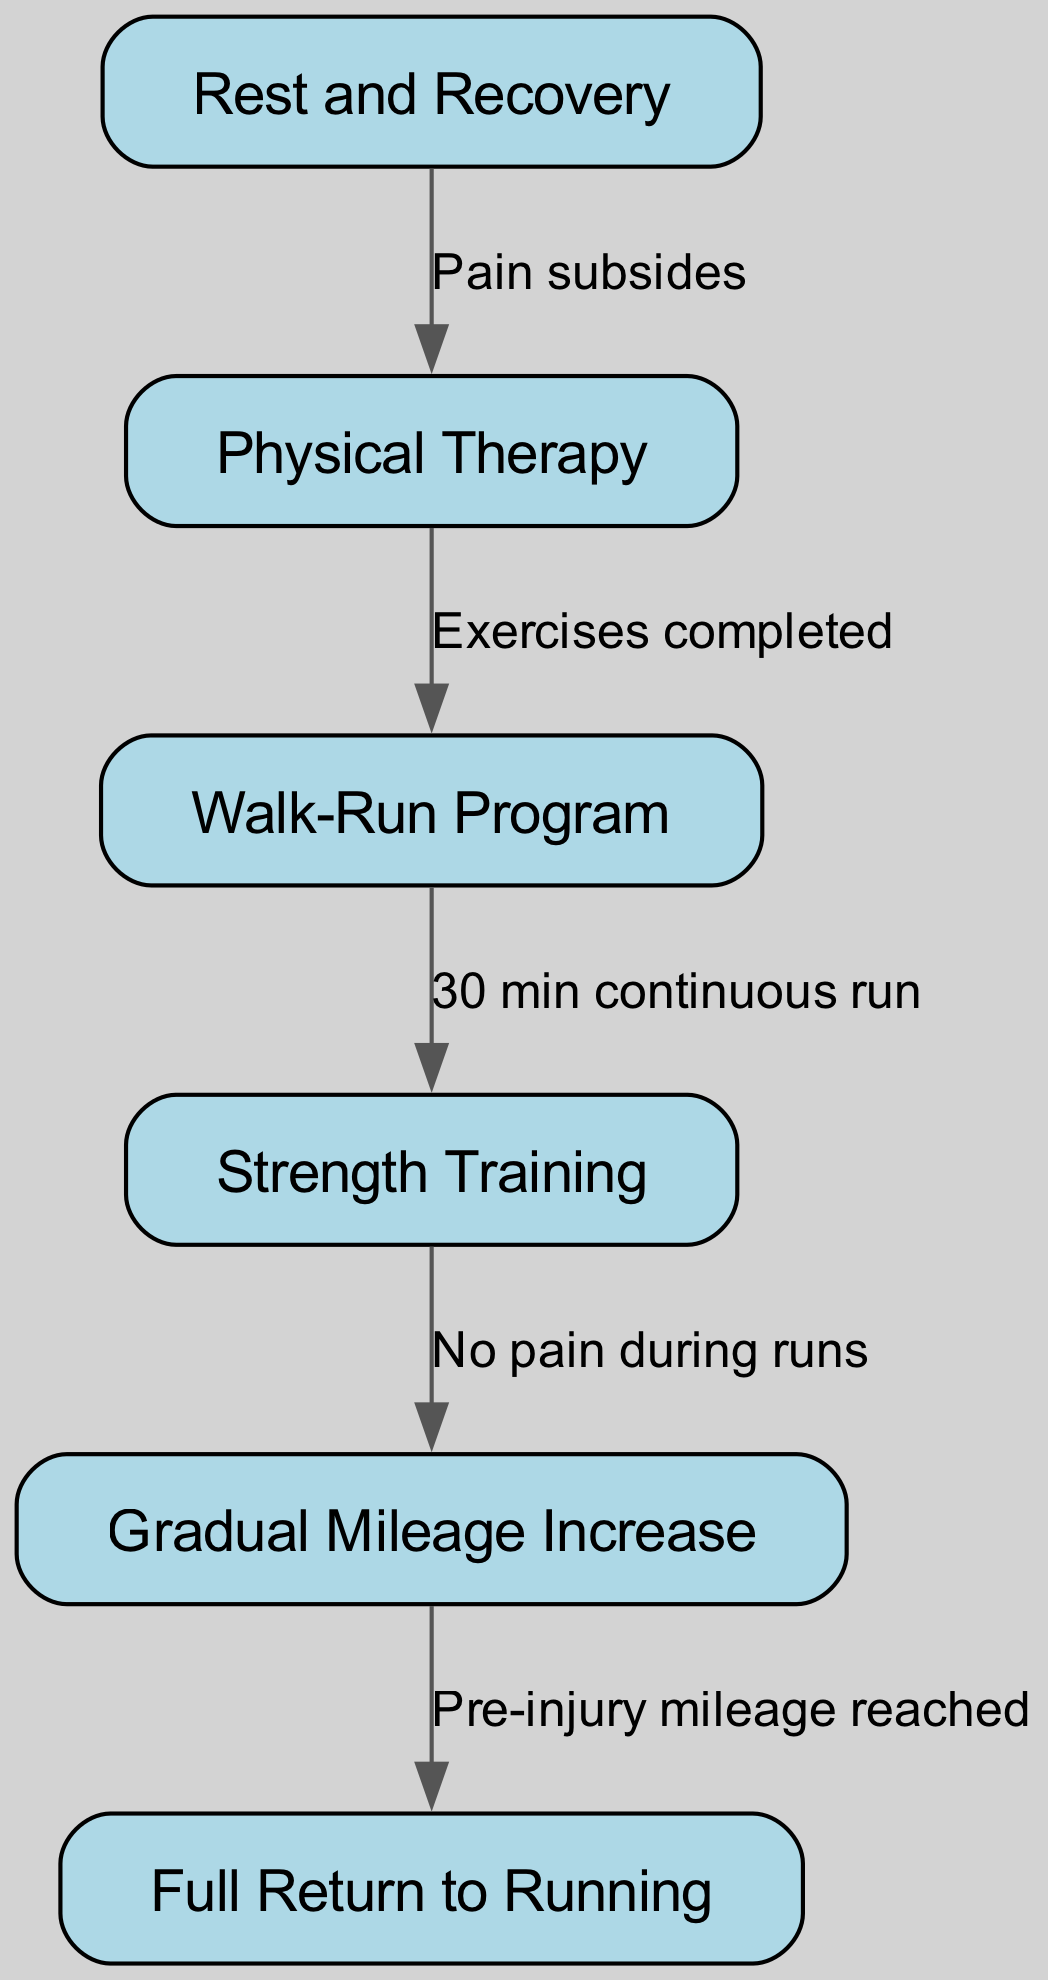What is the first step in the diagram? The first step in the diagram is labeled "Rest and Recovery," which is indicated as the starting node without any incoming edges.
Answer: Rest and Recovery How many nodes are in the diagram? The diagram contains a total of six nodes, each representing a unique step in the return-to-running program.
Answer: 6 What action occurs after "Physical Therapy"? After completing "Physical Therapy," the next action is to begin the "Walk-Run Program," as indicated by the directed edge from node 2 to node 3.
Answer: Walk-Run Program What condition must be met before moving to "Gradual Mileage Increase"? The condition that must be fulfilled is having "No pain during runs," which is necessary before progressing from "Strength Training" to "Gradual Mileage Increase."
Answer: No pain during runs What is the final step in the flow chart? The final step in the flow chart is "Full Return to Running," represented as the end node, which follows the completion of all previous steps.
Answer: Full Return to Running What is the relationship between "Walk-Run Program" and "Strength Training"? The relationship is sequential; you must complete "30 min continuous run" in the "Walk-Run Program" before you can move on to "Strength Training."
Answer: 30 min continuous run What must happen for a runner to transition from "Gradual Mileage Increase" to "Full Return to Running"? The runner must reach "Pre-injury mileage" to transition from "Gradual Mileage Increase" to "Full Return to Running," indicating that they have returned to their previous level of running.
Answer: Pre-injury mileage How many edges connect the nodes in the diagram? There are five edges representing the connections and relationships between the six nodes in the diagram, detailing the progression of steps.
Answer: 5 